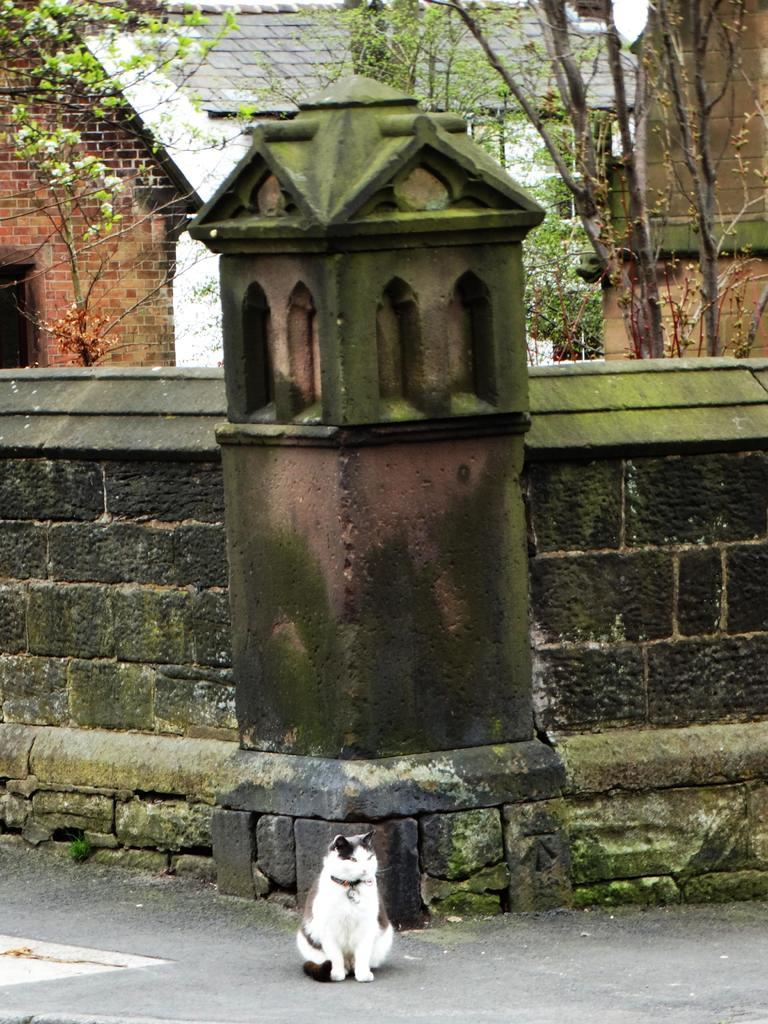What type of animal is in the image? There is a cat in the image. Where is the cat located in the image? The cat is at the bottom of the image. What is behind the cat in the image? There is a wall behind the cat. What can be seen at the top of the image? Trees and houses are visible at the top of the image. What type of poison is the cat consuming in the image? There is no poison present in the image; the cat is not consuming anything. 